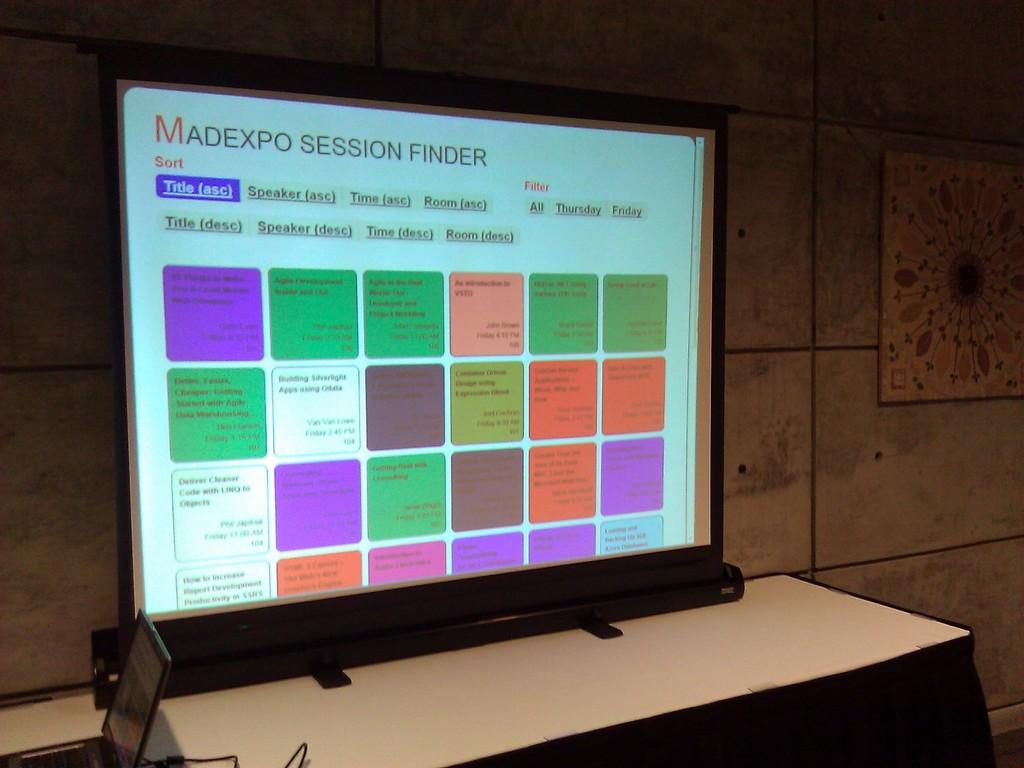Madexpo uses this software to find what?
Offer a very short reply. Sessions. How is this software being sorted?
Your answer should be compact. Title. 